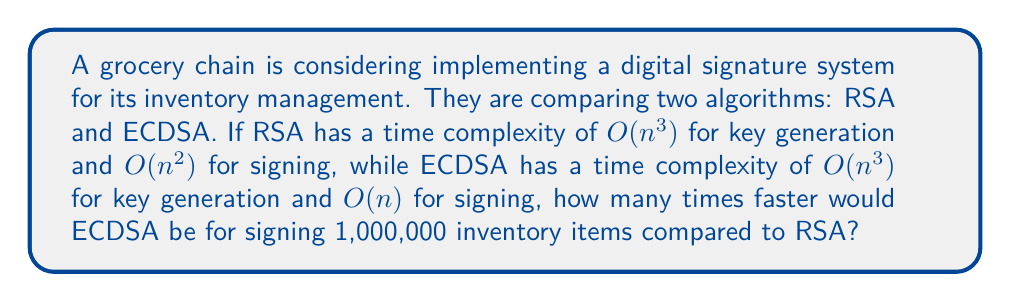Can you answer this question? To solve this problem, we need to compare the time complexities of RSA and ECDSA for signing:

1. RSA signing complexity: $O(n^2)$
2. ECDSA signing complexity: $O(n)$

For large values of n, the difference in time complexity becomes significant. Let's calculate:

1. For RSA: $O(n^2) = O(1,000,000^2) = O(10^{12})$
2. For ECDSA: $O(n) = O(1,000,000) = O(10^6)$

To find how many times faster ECDSA is, we divide the RSA complexity by the ECDSA complexity:

$$\frac{O(10^{12})}{O(10^6)} = O(10^6) = O(1,000,000)$$

This means that for signing 1,000,000 inventory items, ECDSA would be approximately 1,000,000 times faster than RSA.

Note: This is a simplified comparison based on big O notation and doesn't account for constant factors or specific implementations. In practice, the actual speed difference may vary.
Answer: 1,000,000 times faster 